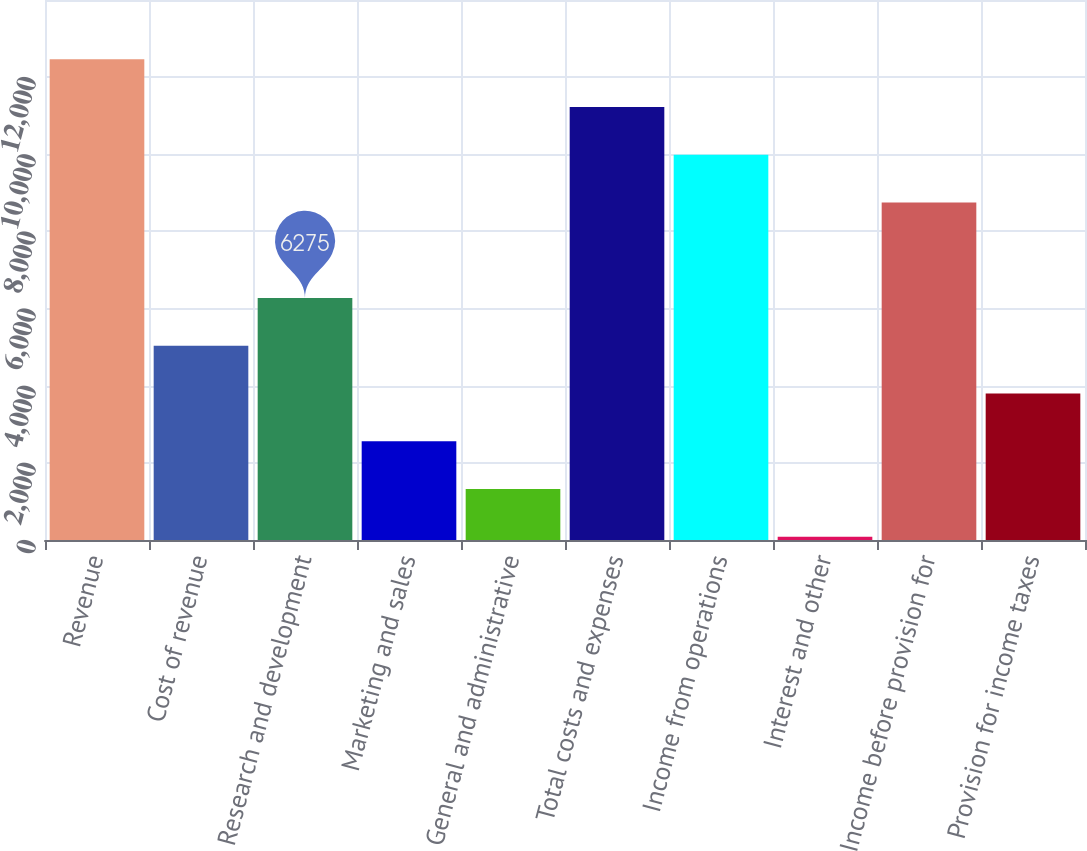<chart> <loc_0><loc_0><loc_500><loc_500><bar_chart><fcel>Revenue<fcel>Cost of revenue<fcel>Research and development<fcel>Marketing and sales<fcel>General and administrative<fcel>Total costs and expenses<fcel>Income from operations<fcel>Interest and other<fcel>Income before provision for<fcel>Provision for income taxes<nl><fcel>12466<fcel>5036.8<fcel>6275<fcel>2560.4<fcel>1322.2<fcel>11227.8<fcel>9989.6<fcel>84<fcel>8751.4<fcel>3798.6<nl></chart> 